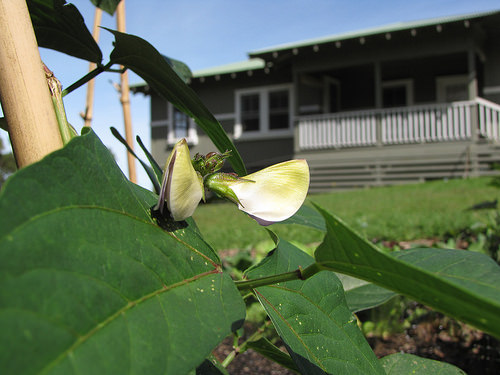<image>
Is the house on the lawn? Yes. Looking at the image, I can see the house is positioned on top of the lawn, with the lawn providing support. 